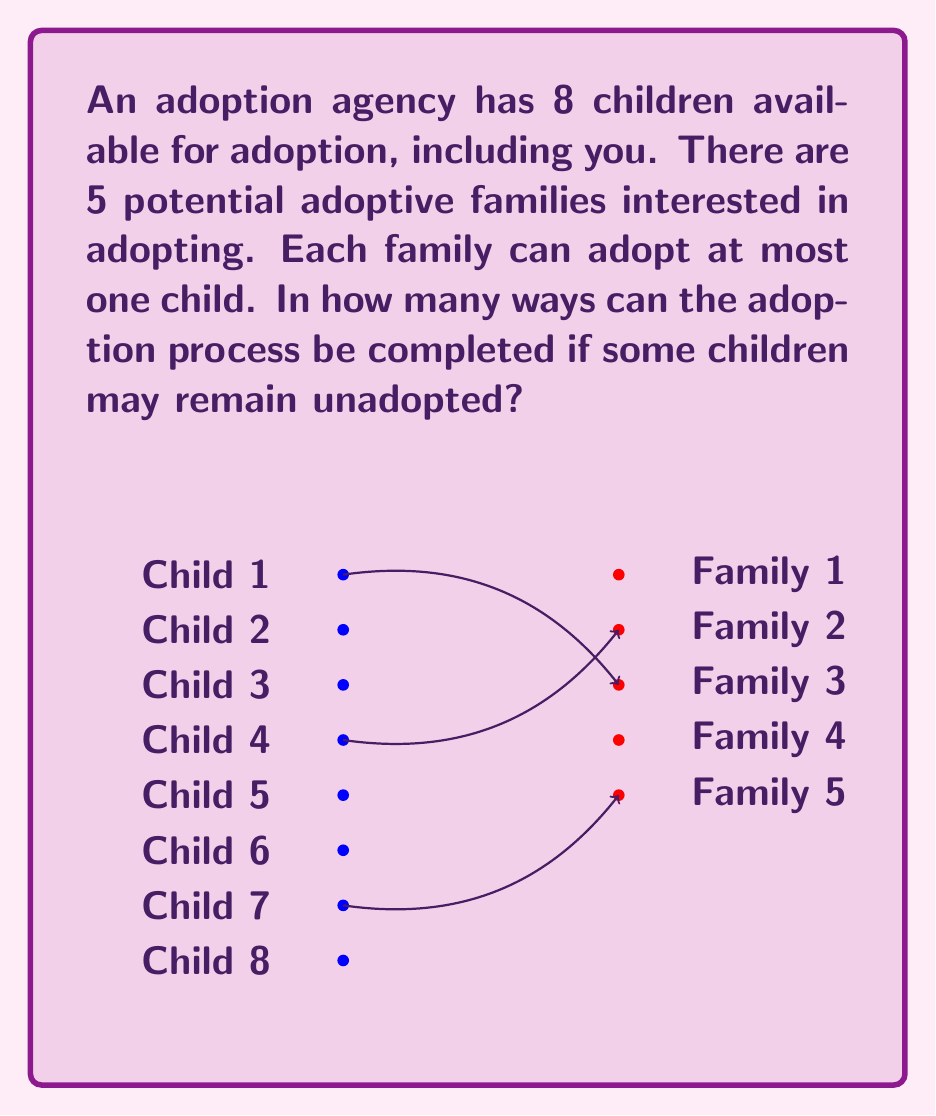Give your solution to this math problem. Let's approach this step-by-step:

1) First, we need to understand what the question is asking. We're looking for the total number of ways to assign children to families, including the possibility of some children remaining unadopted.

2) This is a classic combinatorics problem that can be solved using the concept of functions. We're essentially counting the number of functions from the set of children to the set of families, plus an extra option for each child to remain unadopted.

3) We can think of this as having 6 options for each child: 5 families and 1 option to remain unadopted.

4) Since each child has 6 independent options, and there are 8 children, we can use the multiplication principle.

5) The total number of ways is thus:

   $$ 6^8 $$

6) Let's calculate this:
   $$ 6^8 = 6 \times 6 \times 6 \times 6 \times 6 \times 6 \times 6 \times 6 = 1,679,616 $$

Therefore, there are 1,679,616 possible outcomes for the adoption process.
Answer: 1,679,616 